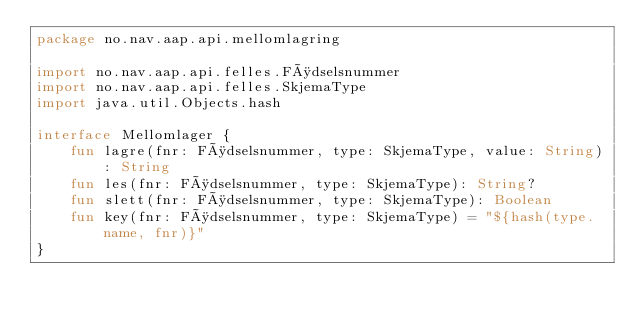<code> <loc_0><loc_0><loc_500><loc_500><_Kotlin_>package no.nav.aap.api.mellomlagring

import no.nav.aap.api.felles.Fødselsnummer
import no.nav.aap.api.felles.SkjemaType
import java.util.Objects.hash

interface Mellomlager {
    fun lagre(fnr: Fødselsnummer, type: SkjemaType, value: String): String
    fun les(fnr: Fødselsnummer, type: SkjemaType): String?
    fun slett(fnr: Fødselsnummer, type: SkjemaType): Boolean
    fun key(fnr: Fødselsnummer, type: SkjemaType) = "${hash(type.name, fnr)}"
}</code> 